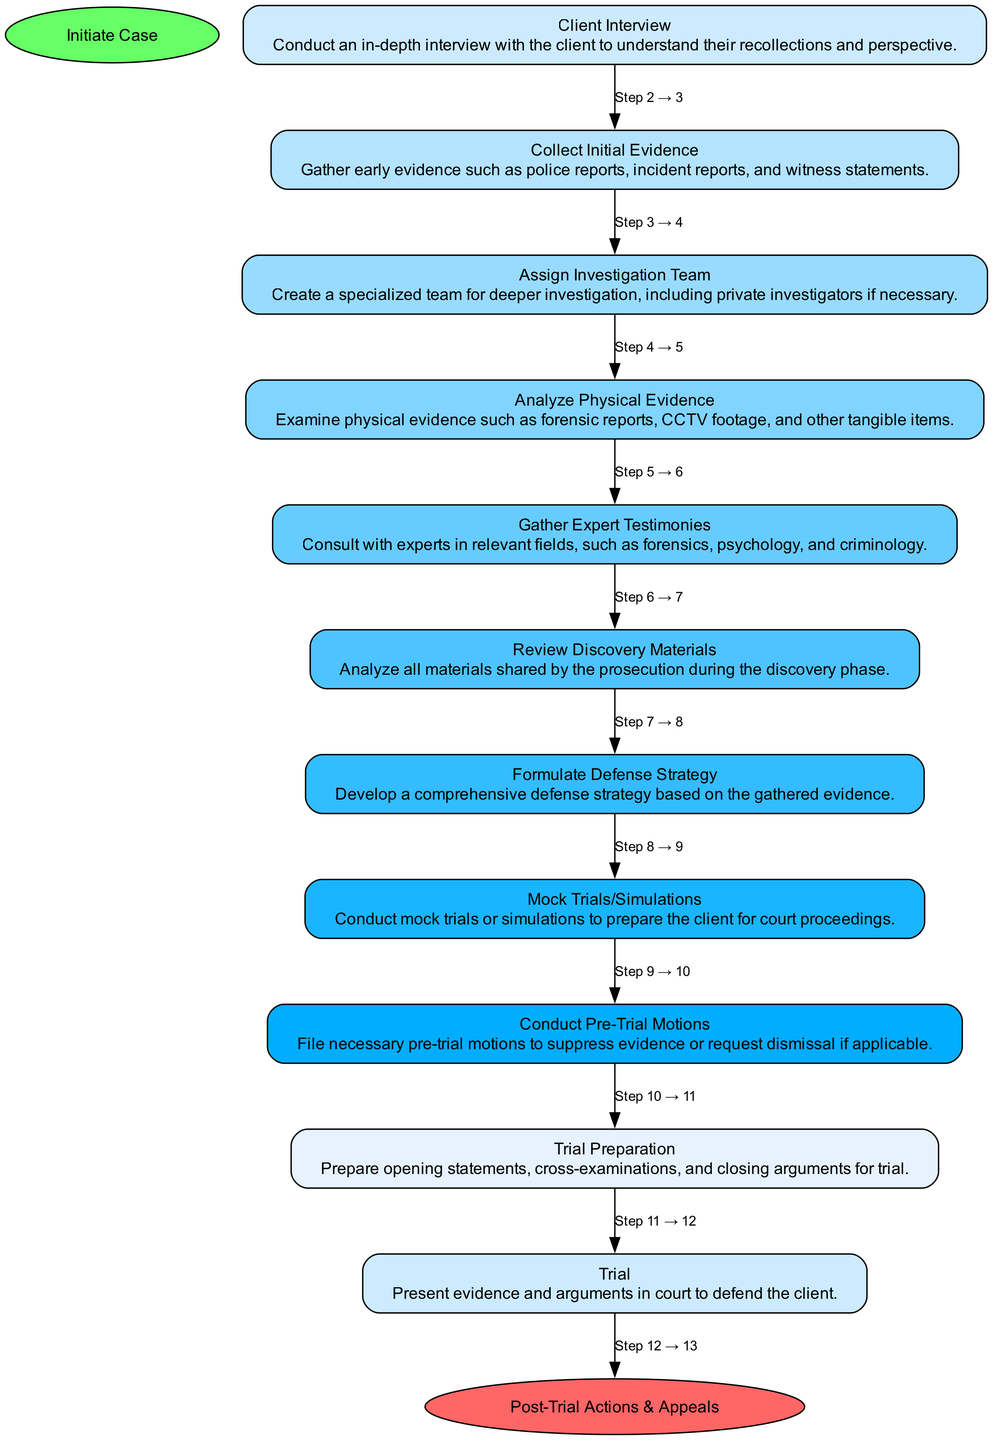What is the first step in the workflow? The first step as indicated in the diagram is labeled "Initiate Case," marking the beginning of the evidence gathering process.
Answer: Initiate Case How many total process nodes are there in the diagram? By counting the nodes labeled as "process," one can see there are ten such nodes, representing different stages of the workflow.
Answer: 10 What step follows "Analyzing Physical Evidence"? According to the diagram, the step that follows "Analyze Physical Evidence" is "Gather Expert Testimonies," which indicates the subsequent action in the workflow.
Answer: Gather Expert Testimonies Which element is described as the endpoint of the diagram? The diagram marks "Post-Trial Actions & Appeals" as the endpoint of the workflow, representing concluding actions after the trial.
Answer: Post-Trial Actions & Appeals What is the primary purpose of the "Client Interview" step? The purpose of the "Client Interview" step is explicitly to conduct an in-depth interview with the client to gather their perspective and recollections regarding the case.
Answer: To understand client perspective Which step precedes "Trial Preparation"? The step that comes directly before "Trial Preparation" is "Conduct Pre-Trial Motions," highlighting the actions necessary to set up before the trial phase.
Answer: Conduct Pre-Trial Motions How many edges connect the nodes in this diagram? By analyzing the connections between nodes, one can note there are twelve edges that illustrate the flow from initiation to conclusion.
Answer: 12 Why is "Formulate Defense Strategy" vital in the workflow? This step is crucial as it involves developing a comprehensive defense strategy based on the totality of evidence gathered throughout previous processes, essential for effective defense.
Answer: To develop a comprehensive defense strategy What type of node is "Trial"? The "Trial" node is categorized as a process type, representing one of the critical stages where evidence and arguments are presented in the court.
Answer: Process 